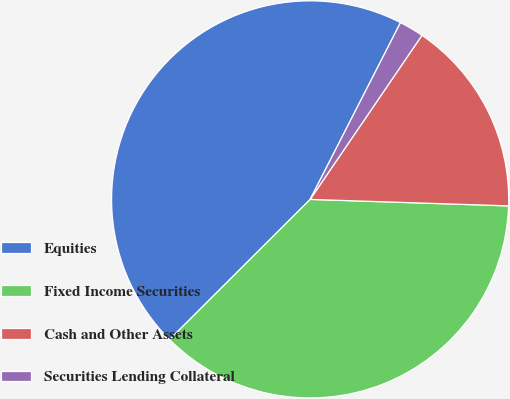<chart> <loc_0><loc_0><loc_500><loc_500><pie_chart><fcel>Equities<fcel>Fixed Income Securities<fcel>Cash and Other Assets<fcel>Securities Lending Collateral<nl><fcel>45.0%<fcel>37.0%<fcel>16.0%<fcel>2.0%<nl></chart> 